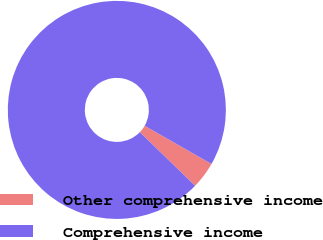Convert chart to OTSL. <chart><loc_0><loc_0><loc_500><loc_500><pie_chart><fcel>Other comprehensive income<fcel>Comprehensive income<nl><fcel>4.0%<fcel>96.0%<nl></chart> 